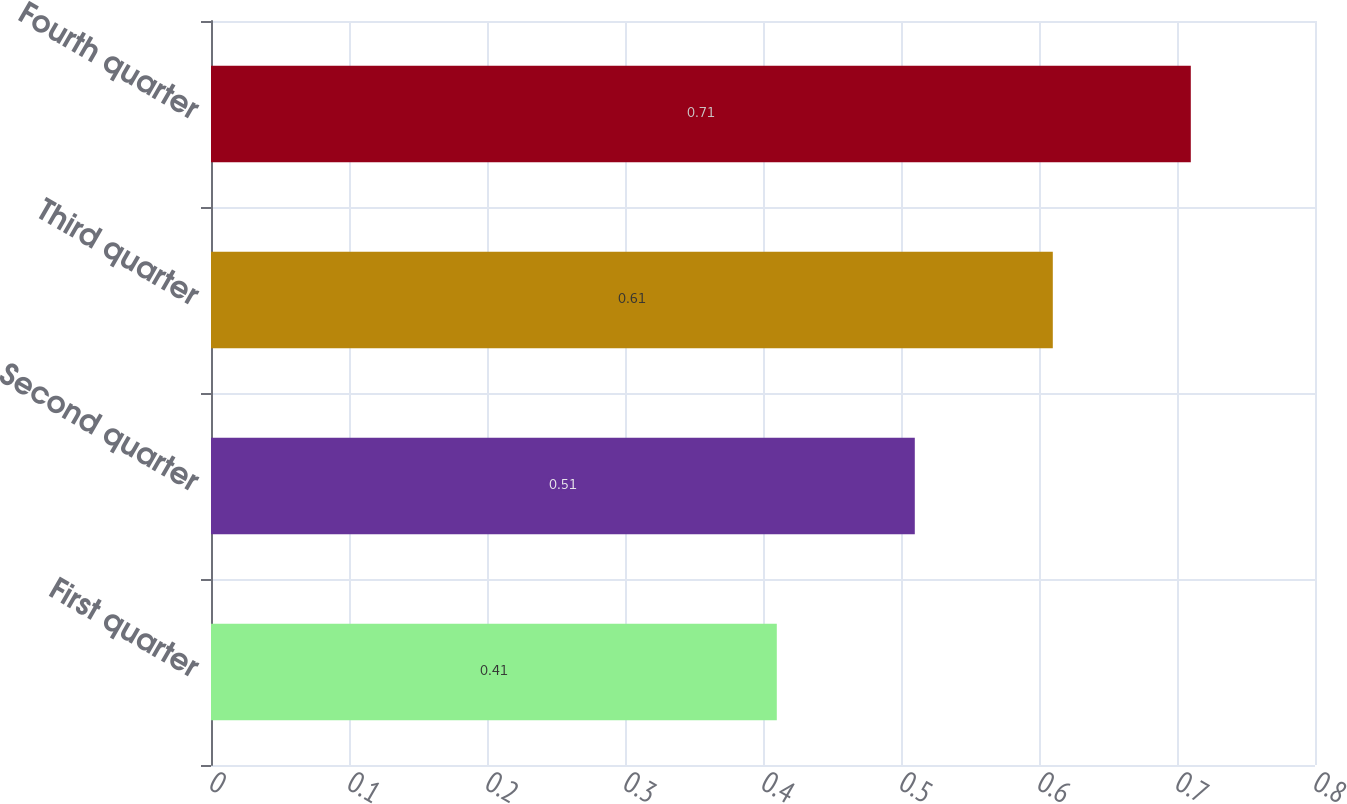<chart> <loc_0><loc_0><loc_500><loc_500><bar_chart><fcel>First quarter<fcel>Second quarter<fcel>Third quarter<fcel>Fourth quarter<nl><fcel>0.41<fcel>0.51<fcel>0.61<fcel>0.71<nl></chart> 